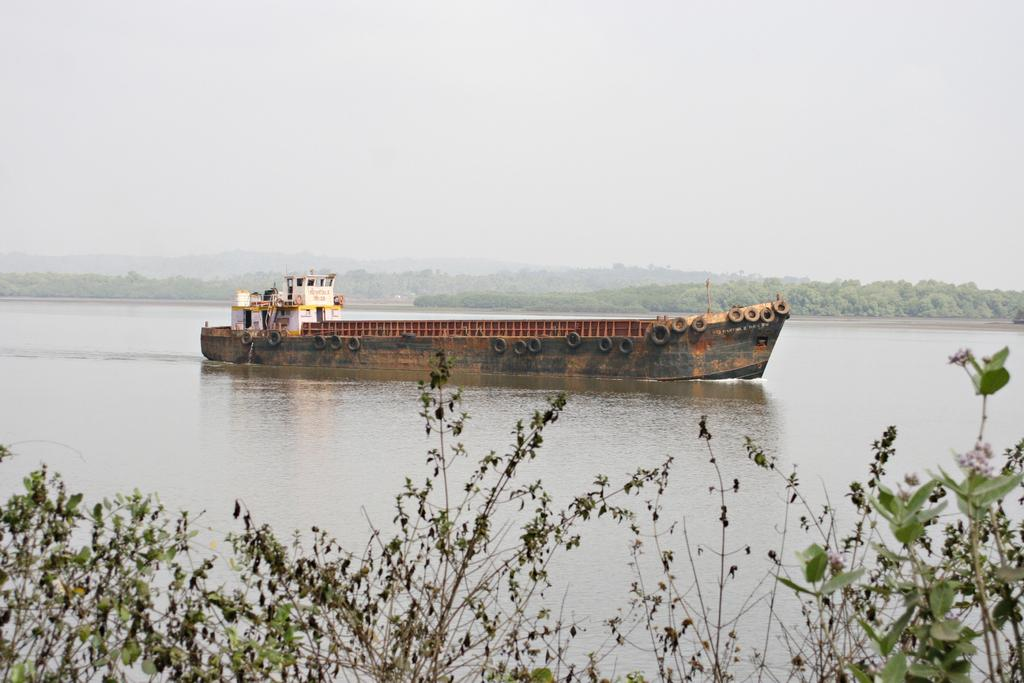What is located in the foreground of the image? There are plants in the foreground of the image. What is floating on the water in the image? A ship is floating on the water in the image. What can be seen in the background of the image? There are trees and the sky visible in the background of the image. What type of drug is being administered to the plants in the image? There is no drug being administered to the plants in the image; they are simply growing in the foreground. What shocking event is happening on the ship in the image? There is no shocking event happening on the ship in the image; it is simply floating on the water. 